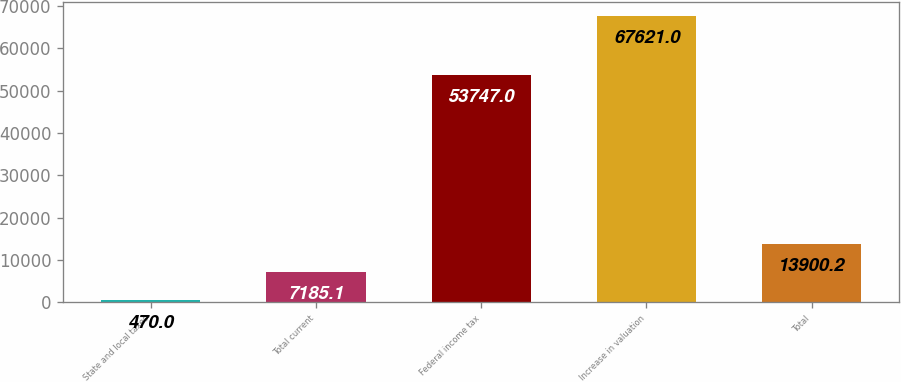Convert chart. <chart><loc_0><loc_0><loc_500><loc_500><bar_chart><fcel>State and local taxes<fcel>Total current<fcel>Federal income tax<fcel>Increase in valuation<fcel>Total<nl><fcel>470<fcel>7185.1<fcel>53747<fcel>67621<fcel>13900.2<nl></chart> 